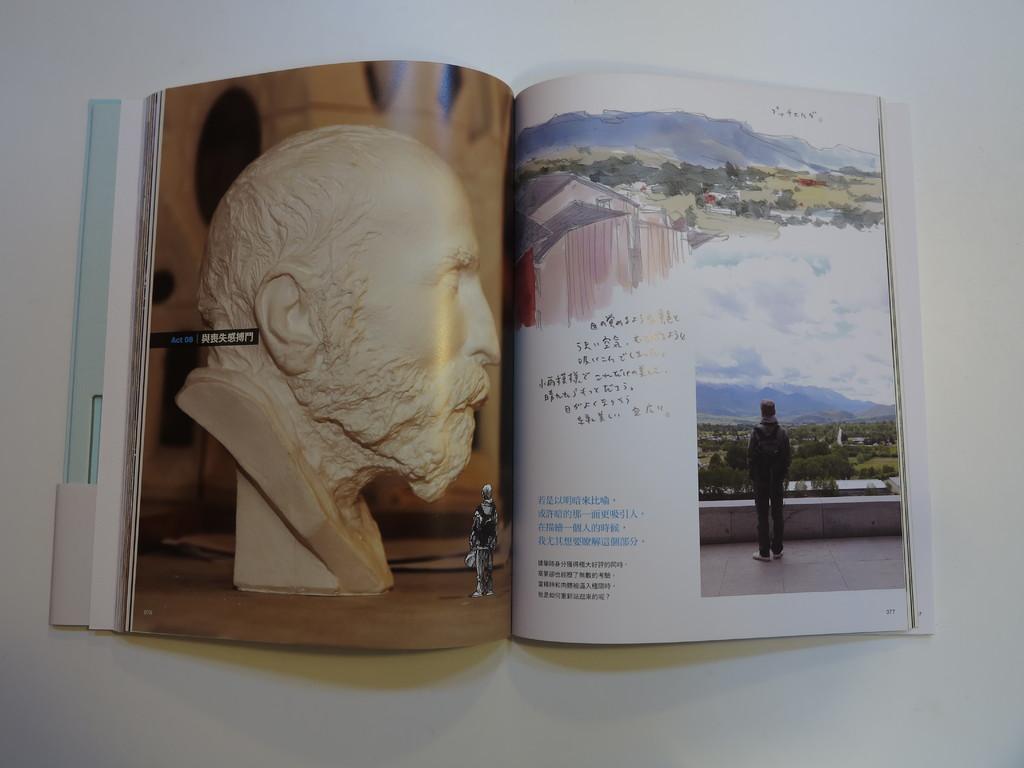What 2 numbers are on the left page?
Provide a succinct answer. Unanswerable. 